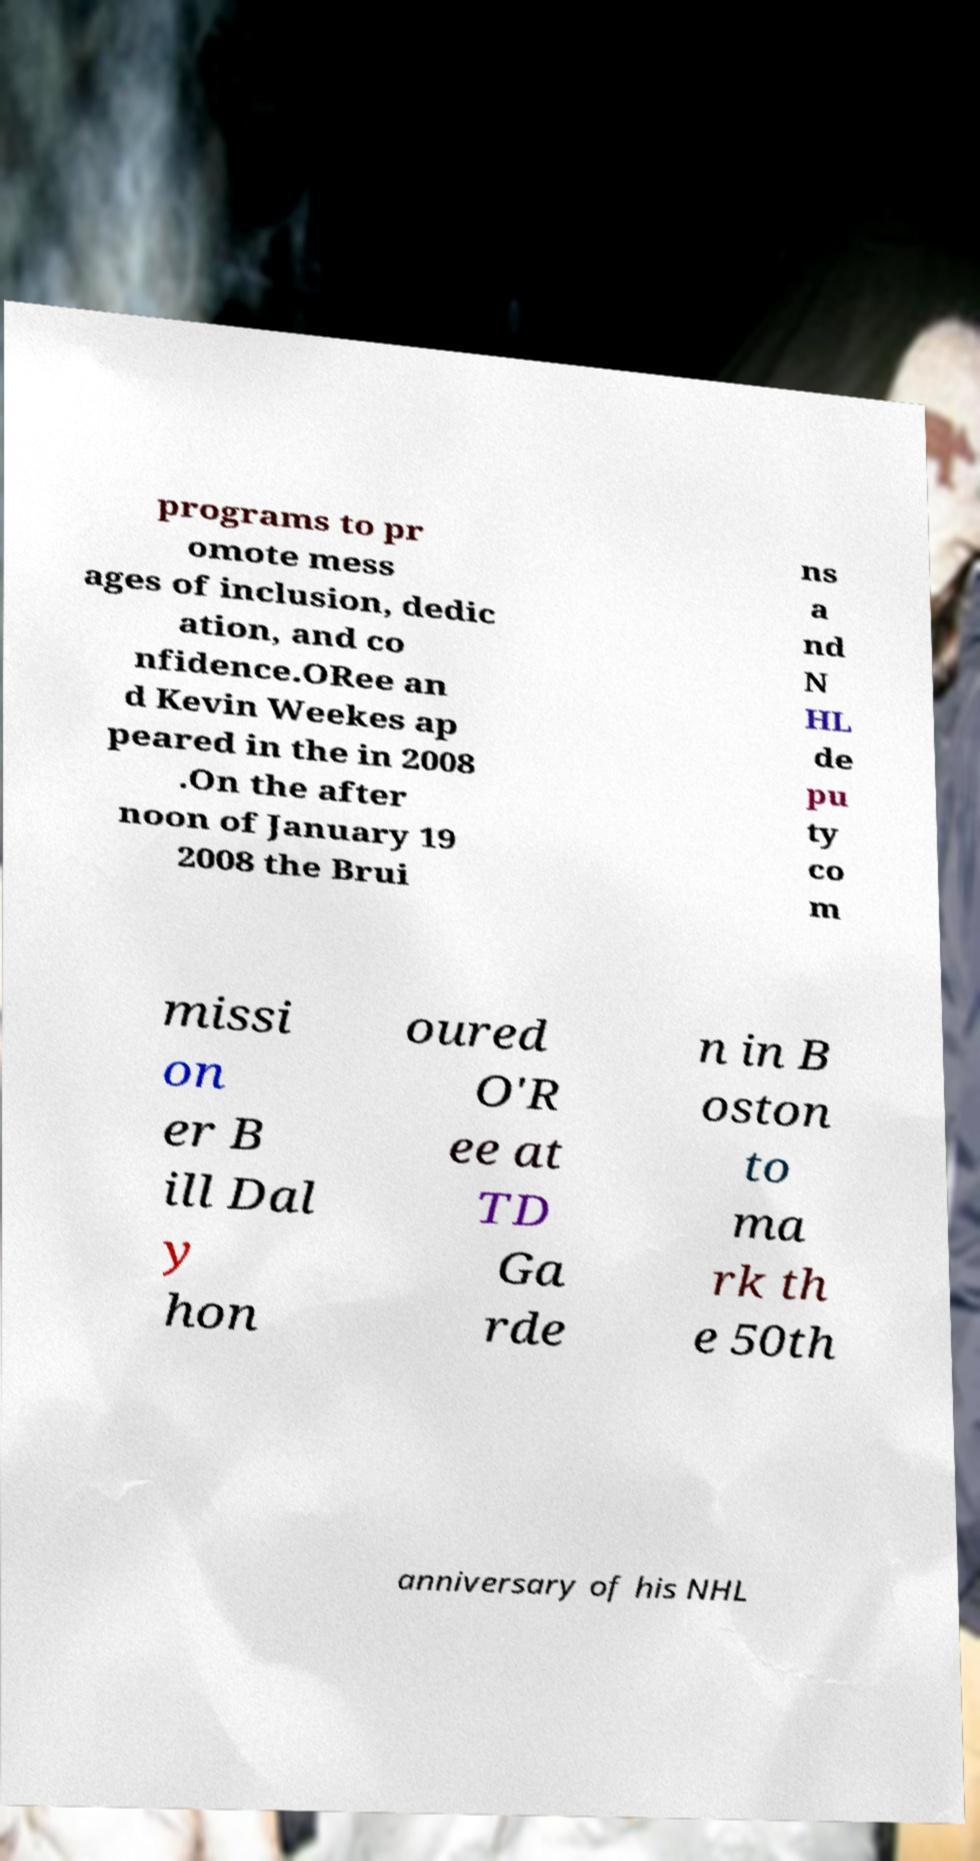Can you accurately transcribe the text from the provided image for me? programs to pr omote mess ages of inclusion, dedic ation, and co nfidence.ORee an d Kevin Weekes ap peared in the in 2008 .On the after noon of January 19 2008 the Brui ns a nd N HL de pu ty co m missi on er B ill Dal y hon oured O'R ee at TD Ga rde n in B oston to ma rk th e 50th anniversary of his NHL 